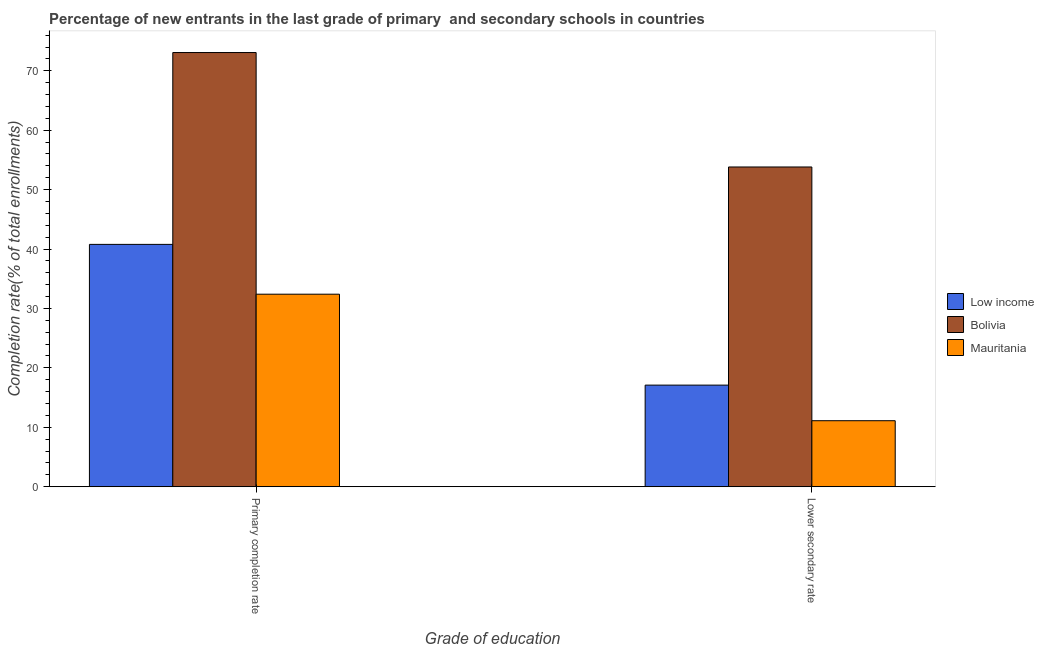How many groups of bars are there?
Offer a terse response. 2. Are the number of bars per tick equal to the number of legend labels?
Give a very brief answer. Yes. How many bars are there on the 1st tick from the right?
Offer a very short reply. 3. What is the label of the 2nd group of bars from the left?
Ensure brevity in your answer.  Lower secondary rate. What is the completion rate in primary schools in Mauritania?
Your answer should be very brief. 32.4. Across all countries, what is the maximum completion rate in primary schools?
Your answer should be very brief. 73.07. Across all countries, what is the minimum completion rate in primary schools?
Offer a terse response. 32.4. In which country was the completion rate in secondary schools maximum?
Your answer should be compact. Bolivia. In which country was the completion rate in secondary schools minimum?
Give a very brief answer. Mauritania. What is the total completion rate in secondary schools in the graph?
Ensure brevity in your answer.  82.02. What is the difference between the completion rate in primary schools in Low income and that in Bolivia?
Offer a terse response. -32.28. What is the difference between the completion rate in secondary schools in Bolivia and the completion rate in primary schools in Low income?
Provide a short and direct response. 13.02. What is the average completion rate in secondary schools per country?
Keep it short and to the point. 27.34. What is the difference between the completion rate in primary schools and completion rate in secondary schools in Bolivia?
Provide a short and direct response. 19.26. What is the ratio of the completion rate in primary schools in Mauritania to that in Low income?
Offer a very short reply. 0.79. In how many countries, is the completion rate in primary schools greater than the average completion rate in primary schools taken over all countries?
Offer a very short reply. 1. What does the 1st bar from the left in Primary completion rate represents?
Make the answer very short. Low income. Are all the bars in the graph horizontal?
Keep it short and to the point. No. How many countries are there in the graph?
Your answer should be compact. 3. What is the difference between two consecutive major ticks on the Y-axis?
Your response must be concise. 10. Are the values on the major ticks of Y-axis written in scientific E-notation?
Ensure brevity in your answer.  No. Does the graph contain any zero values?
Ensure brevity in your answer.  No. Where does the legend appear in the graph?
Your answer should be very brief. Center right. How many legend labels are there?
Your answer should be very brief. 3. How are the legend labels stacked?
Make the answer very short. Vertical. What is the title of the graph?
Provide a short and direct response. Percentage of new entrants in the last grade of primary  and secondary schools in countries. What is the label or title of the X-axis?
Your answer should be compact. Grade of education. What is the label or title of the Y-axis?
Your answer should be compact. Completion rate(% of total enrollments). What is the Completion rate(% of total enrollments) of Low income in Primary completion rate?
Your response must be concise. 40.78. What is the Completion rate(% of total enrollments) in Bolivia in Primary completion rate?
Keep it short and to the point. 73.07. What is the Completion rate(% of total enrollments) in Mauritania in Primary completion rate?
Give a very brief answer. 32.4. What is the Completion rate(% of total enrollments) of Low income in Lower secondary rate?
Ensure brevity in your answer.  17.1. What is the Completion rate(% of total enrollments) of Bolivia in Lower secondary rate?
Your answer should be compact. 53.81. What is the Completion rate(% of total enrollments) in Mauritania in Lower secondary rate?
Keep it short and to the point. 11.11. Across all Grade of education, what is the maximum Completion rate(% of total enrollments) of Low income?
Keep it short and to the point. 40.78. Across all Grade of education, what is the maximum Completion rate(% of total enrollments) in Bolivia?
Offer a very short reply. 73.07. Across all Grade of education, what is the maximum Completion rate(% of total enrollments) of Mauritania?
Give a very brief answer. 32.4. Across all Grade of education, what is the minimum Completion rate(% of total enrollments) in Low income?
Provide a succinct answer. 17.1. Across all Grade of education, what is the minimum Completion rate(% of total enrollments) of Bolivia?
Ensure brevity in your answer.  53.81. Across all Grade of education, what is the minimum Completion rate(% of total enrollments) of Mauritania?
Give a very brief answer. 11.11. What is the total Completion rate(% of total enrollments) of Low income in the graph?
Provide a short and direct response. 57.88. What is the total Completion rate(% of total enrollments) in Bolivia in the graph?
Offer a terse response. 126.88. What is the total Completion rate(% of total enrollments) of Mauritania in the graph?
Your answer should be very brief. 43.51. What is the difference between the Completion rate(% of total enrollments) of Low income in Primary completion rate and that in Lower secondary rate?
Give a very brief answer. 23.68. What is the difference between the Completion rate(% of total enrollments) in Bolivia in Primary completion rate and that in Lower secondary rate?
Provide a short and direct response. 19.26. What is the difference between the Completion rate(% of total enrollments) in Mauritania in Primary completion rate and that in Lower secondary rate?
Make the answer very short. 21.29. What is the difference between the Completion rate(% of total enrollments) in Low income in Primary completion rate and the Completion rate(% of total enrollments) in Bolivia in Lower secondary rate?
Offer a terse response. -13.02. What is the difference between the Completion rate(% of total enrollments) of Low income in Primary completion rate and the Completion rate(% of total enrollments) of Mauritania in Lower secondary rate?
Your answer should be compact. 29.68. What is the difference between the Completion rate(% of total enrollments) in Bolivia in Primary completion rate and the Completion rate(% of total enrollments) in Mauritania in Lower secondary rate?
Your response must be concise. 61.96. What is the average Completion rate(% of total enrollments) of Low income per Grade of education?
Your answer should be very brief. 28.94. What is the average Completion rate(% of total enrollments) of Bolivia per Grade of education?
Offer a very short reply. 63.44. What is the average Completion rate(% of total enrollments) of Mauritania per Grade of education?
Provide a short and direct response. 21.75. What is the difference between the Completion rate(% of total enrollments) of Low income and Completion rate(% of total enrollments) of Bolivia in Primary completion rate?
Give a very brief answer. -32.28. What is the difference between the Completion rate(% of total enrollments) in Low income and Completion rate(% of total enrollments) in Mauritania in Primary completion rate?
Provide a short and direct response. 8.38. What is the difference between the Completion rate(% of total enrollments) of Bolivia and Completion rate(% of total enrollments) of Mauritania in Primary completion rate?
Your answer should be compact. 40.67. What is the difference between the Completion rate(% of total enrollments) of Low income and Completion rate(% of total enrollments) of Bolivia in Lower secondary rate?
Provide a succinct answer. -36.71. What is the difference between the Completion rate(% of total enrollments) in Low income and Completion rate(% of total enrollments) in Mauritania in Lower secondary rate?
Ensure brevity in your answer.  5.99. What is the difference between the Completion rate(% of total enrollments) in Bolivia and Completion rate(% of total enrollments) in Mauritania in Lower secondary rate?
Offer a terse response. 42.7. What is the ratio of the Completion rate(% of total enrollments) in Low income in Primary completion rate to that in Lower secondary rate?
Offer a very short reply. 2.39. What is the ratio of the Completion rate(% of total enrollments) in Bolivia in Primary completion rate to that in Lower secondary rate?
Provide a succinct answer. 1.36. What is the ratio of the Completion rate(% of total enrollments) of Mauritania in Primary completion rate to that in Lower secondary rate?
Provide a succinct answer. 2.92. What is the difference between the highest and the second highest Completion rate(% of total enrollments) in Low income?
Offer a very short reply. 23.68. What is the difference between the highest and the second highest Completion rate(% of total enrollments) of Bolivia?
Make the answer very short. 19.26. What is the difference between the highest and the second highest Completion rate(% of total enrollments) in Mauritania?
Your response must be concise. 21.29. What is the difference between the highest and the lowest Completion rate(% of total enrollments) of Low income?
Provide a succinct answer. 23.68. What is the difference between the highest and the lowest Completion rate(% of total enrollments) in Bolivia?
Provide a short and direct response. 19.26. What is the difference between the highest and the lowest Completion rate(% of total enrollments) in Mauritania?
Provide a succinct answer. 21.29. 